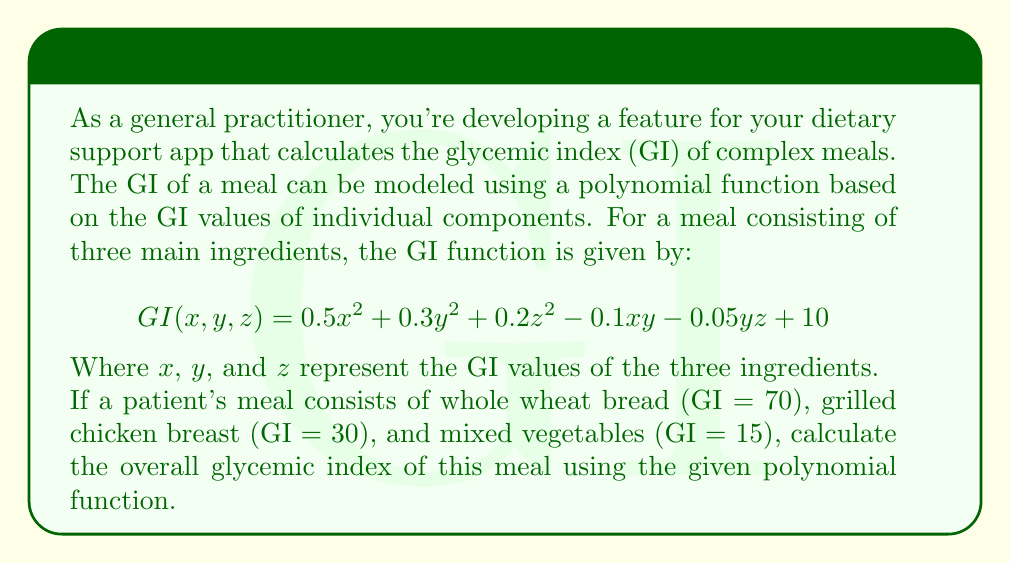Teach me how to tackle this problem. To calculate the glycemic index of the complex meal, we need to substitute the GI values of the individual components into the given polynomial function:

$x = 70$ (whole wheat bread)
$y = 30$ (grilled chicken breast)
$z = 15$ (mixed vegetables)

Let's substitute these values into the function:

$$GI(70, 30, 15) = 0.5(70)^2 + 0.3(30)^2 + 0.2(15)^2 - 0.1(70)(30) - 0.05(30)(15) + 10$$

Now, let's calculate each term:

1. $0.5(70)^2 = 0.5 \times 4900 = 2450$
2. $0.3(30)^2 = 0.3 \times 900 = 270$
3. $0.2(15)^2 = 0.2 \times 225 = 45$
4. $-0.1(70)(30) = -0.1 \times 2100 = -210$
5. $-0.05(30)(15) = -0.05 \times 450 = -22.5$
6. $+10$

Adding all these terms:

$$GI = 2450 + 270 + 45 - 210 - 22.5 + 10 = 2542.5$$

Therefore, the overall glycemic index of the meal is approximately 2542.5.
Answer: 2542.5 